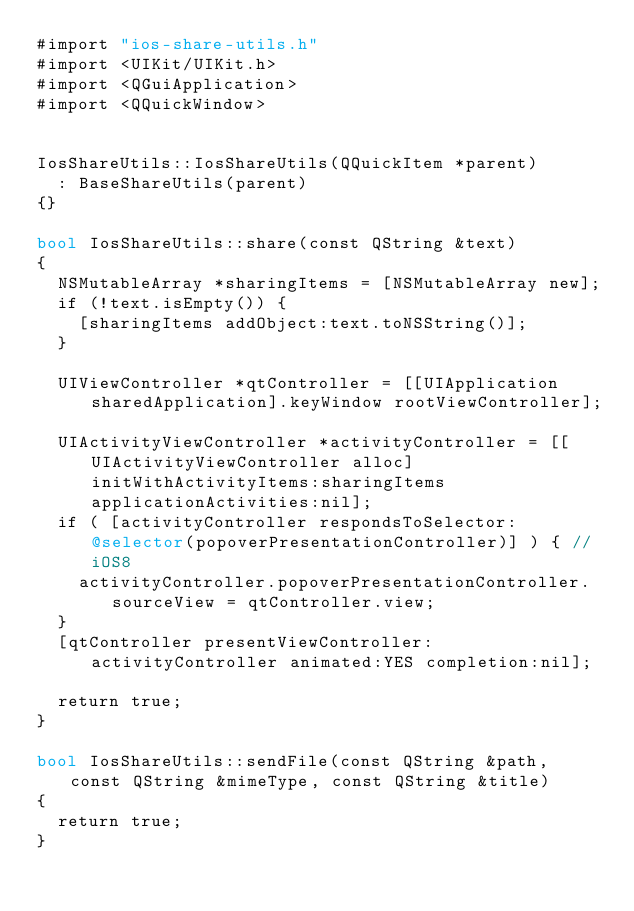<code> <loc_0><loc_0><loc_500><loc_500><_ObjectiveC_>#import "ios-share-utils.h"
#import <UIKit/UIKit.h>
#import <QGuiApplication>
#import <QQuickWindow>


IosShareUtils::IosShareUtils(QQuickItem *parent)
	: BaseShareUtils(parent)
{}

bool IosShareUtils::share(const QString &text)
{
	NSMutableArray *sharingItems = [NSMutableArray new];
	if (!text.isEmpty()) {
		[sharingItems addObject:text.toNSString()];
	}

	UIViewController *qtController = [[UIApplication sharedApplication].keyWindow rootViewController];

	UIActivityViewController *activityController = [[UIActivityViewController alloc] initWithActivityItems:sharingItems applicationActivities:nil];
	if ( [activityController respondsToSelector:@selector(popoverPresentationController)] ) { // iOS8
		activityController.popoverPresentationController.sourceView = qtController.view;
	}
	[qtController presentViewController:activityController animated:YES completion:nil];

	return true;
}

bool IosShareUtils::sendFile(const QString &path, const QString &mimeType, const QString &title)
{
	return true;
}
</code> 